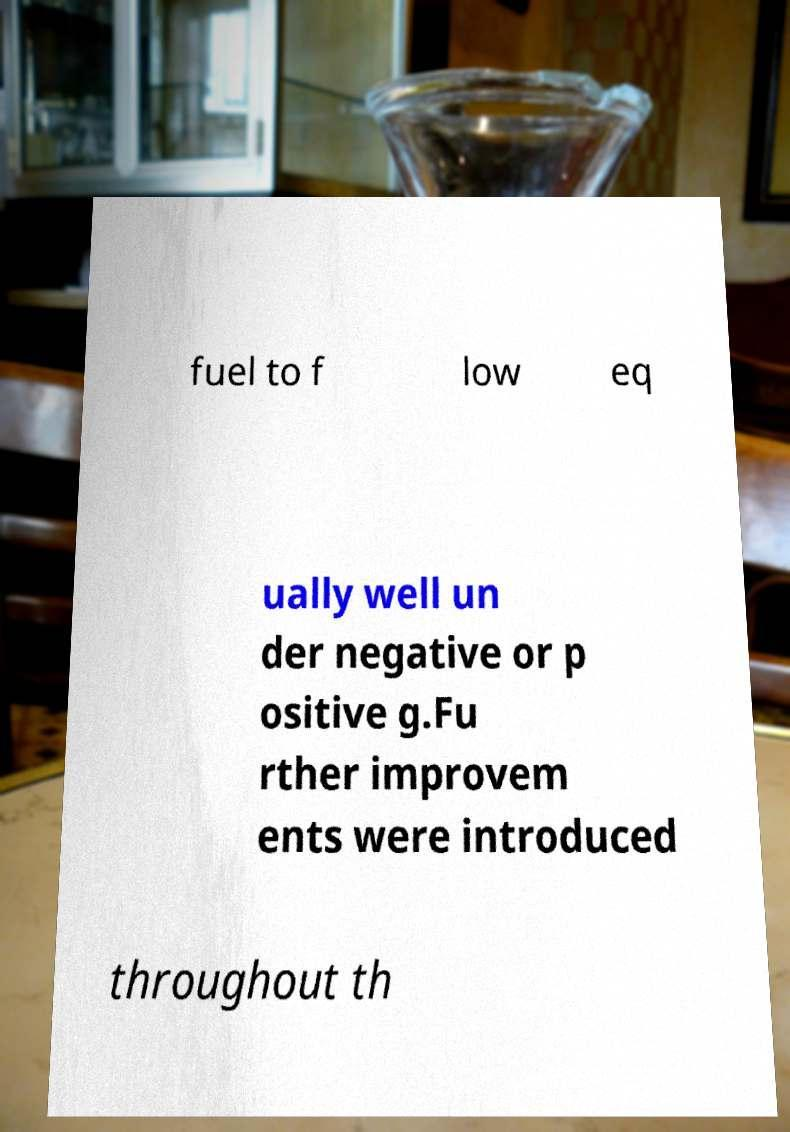There's text embedded in this image that I need extracted. Can you transcribe it verbatim? fuel to f low eq ually well un der negative or p ositive g.Fu rther improvem ents were introduced throughout th 